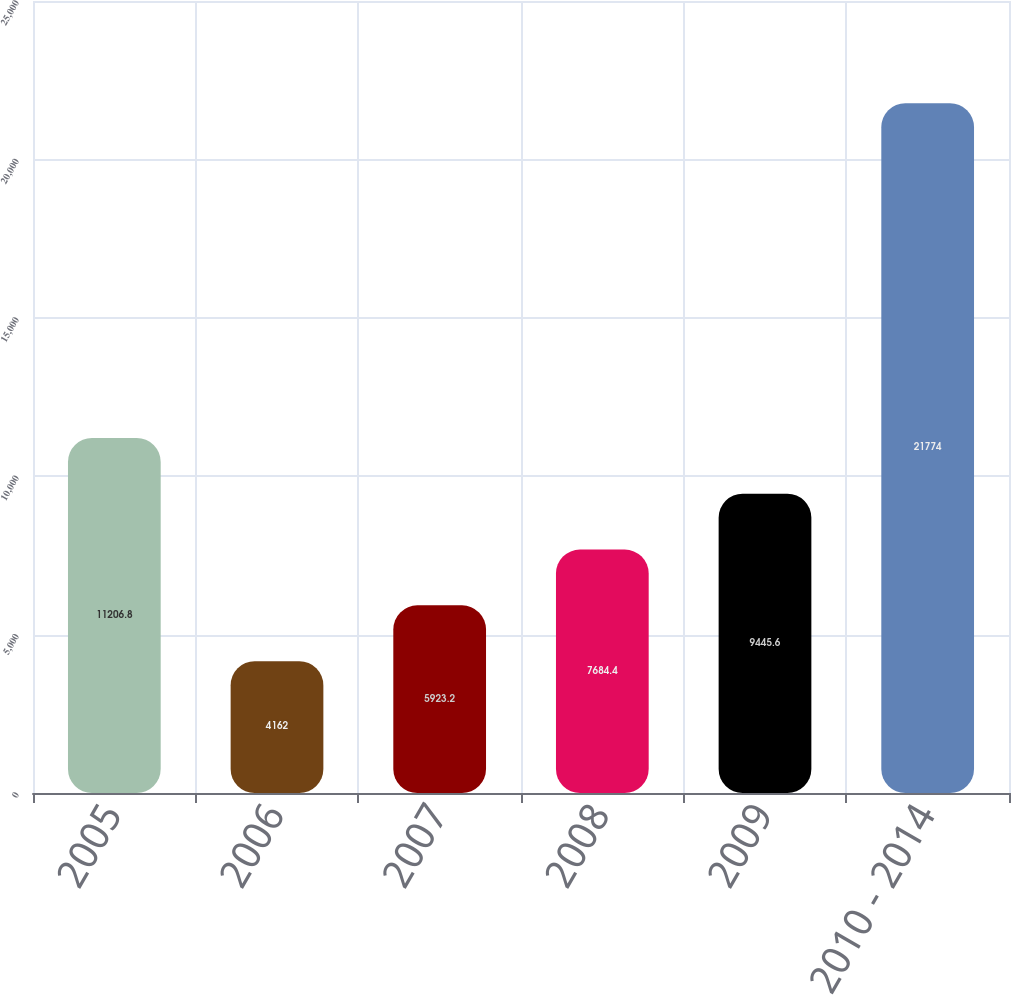Convert chart to OTSL. <chart><loc_0><loc_0><loc_500><loc_500><bar_chart><fcel>2005<fcel>2006<fcel>2007<fcel>2008<fcel>2009<fcel>2010 - 2014<nl><fcel>11206.8<fcel>4162<fcel>5923.2<fcel>7684.4<fcel>9445.6<fcel>21774<nl></chart> 